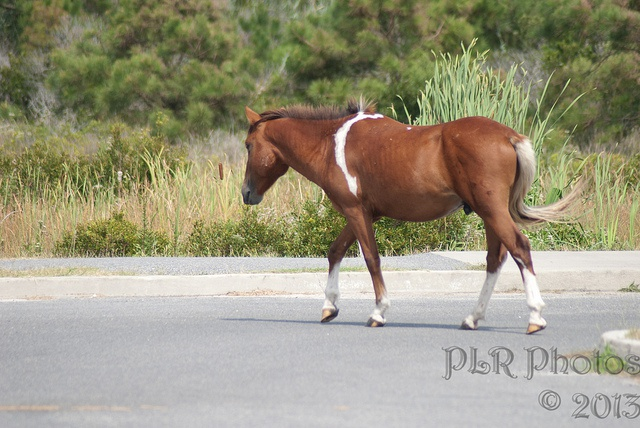Describe the objects in this image and their specific colors. I can see a horse in darkgreen, maroon, and brown tones in this image. 